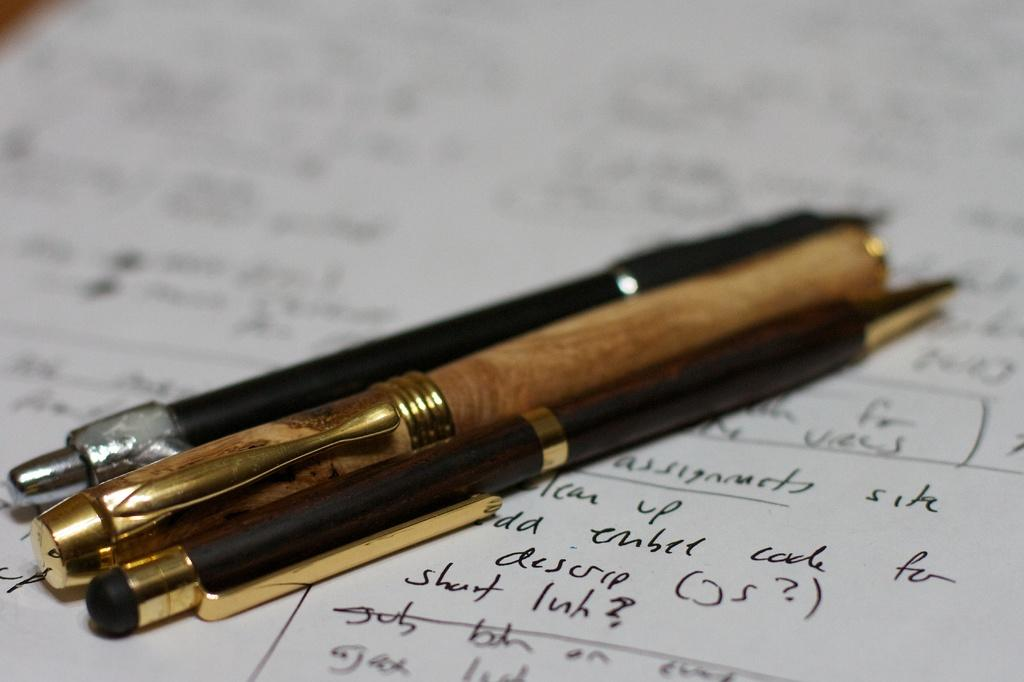<image>
Create a compact narrative representing the image presented. Three pens on a piece of paper that has scribbling in a language other than English on it. 